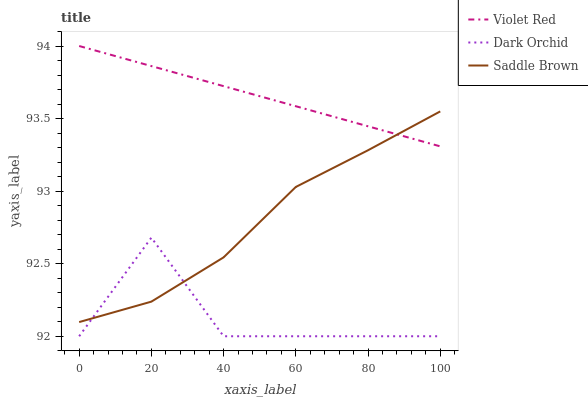Does Dark Orchid have the minimum area under the curve?
Answer yes or no. Yes. Does Violet Red have the maximum area under the curve?
Answer yes or no. Yes. Does Saddle Brown have the minimum area under the curve?
Answer yes or no. No. Does Saddle Brown have the maximum area under the curve?
Answer yes or no. No. Is Violet Red the smoothest?
Answer yes or no. Yes. Is Dark Orchid the roughest?
Answer yes or no. Yes. Is Saddle Brown the smoothest?
Answer yes or no. No. Is Saddle Brown the roughest?
Answer yes or no. No. Does Dark Orchid have the lowest value?
Answer yes or no. Yes. Does Saddle Brown have the lowest value?
Answer yes or no. No. Does Violet Red have the highest value?
Answer yes or no. Yes. Does Saddle Brown have the highest value?
Answer yes or no. No. Is Dark Orchid less than Violet Red?
Answer yes or no. Yes. Is Violet Red greater than Dark Orchid?
Answer yes or no. Yes. Does Saddle Brown intersect Violet Red?
Answer yes or no. Yes. Is Saddle Brown less than Violet Red?
Answer yes or no. No. Is Saddle Brown greater than Violet Red?
Answer yes or no. No. Does Dark Orchid intersect Violet Red?
Answer yes or no. No. 